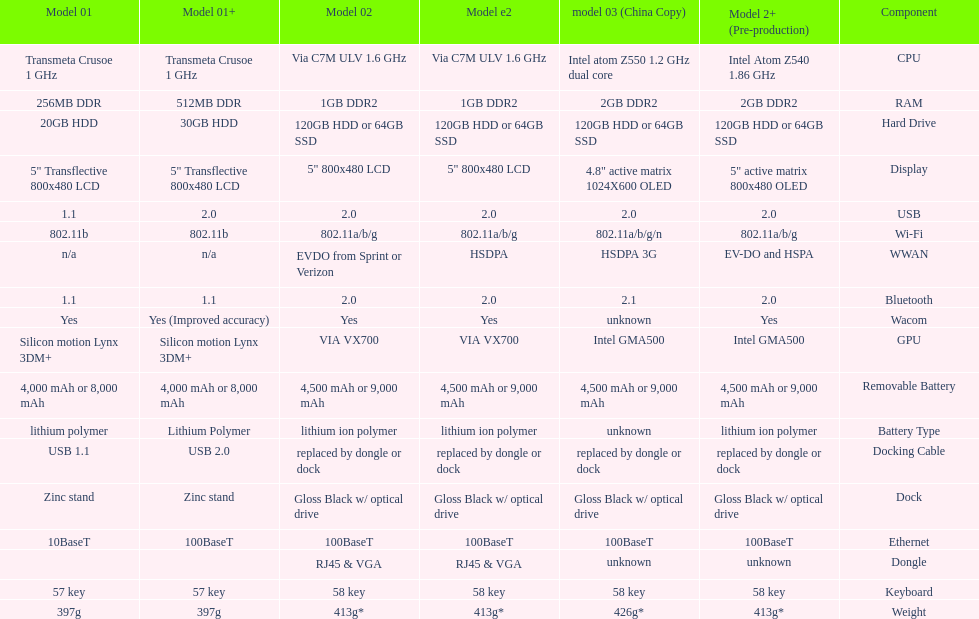What is the next highest hard drive available after the 30gb model? 64GB SSD. 